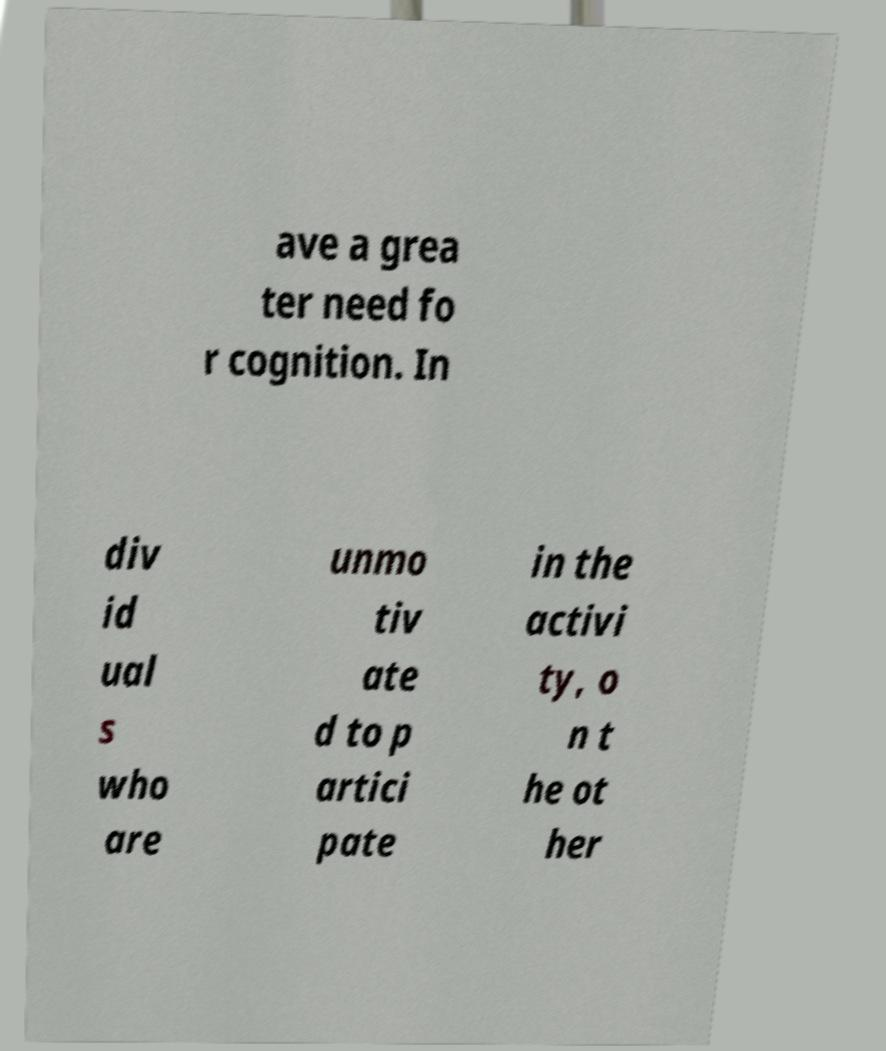Please read and relay the text visible in this image. What does it say? ave a grea ter need fo r cognition. In div id ual s who are unmo tiv ate d to p artici pate in the activi ty, o n t he ot her 